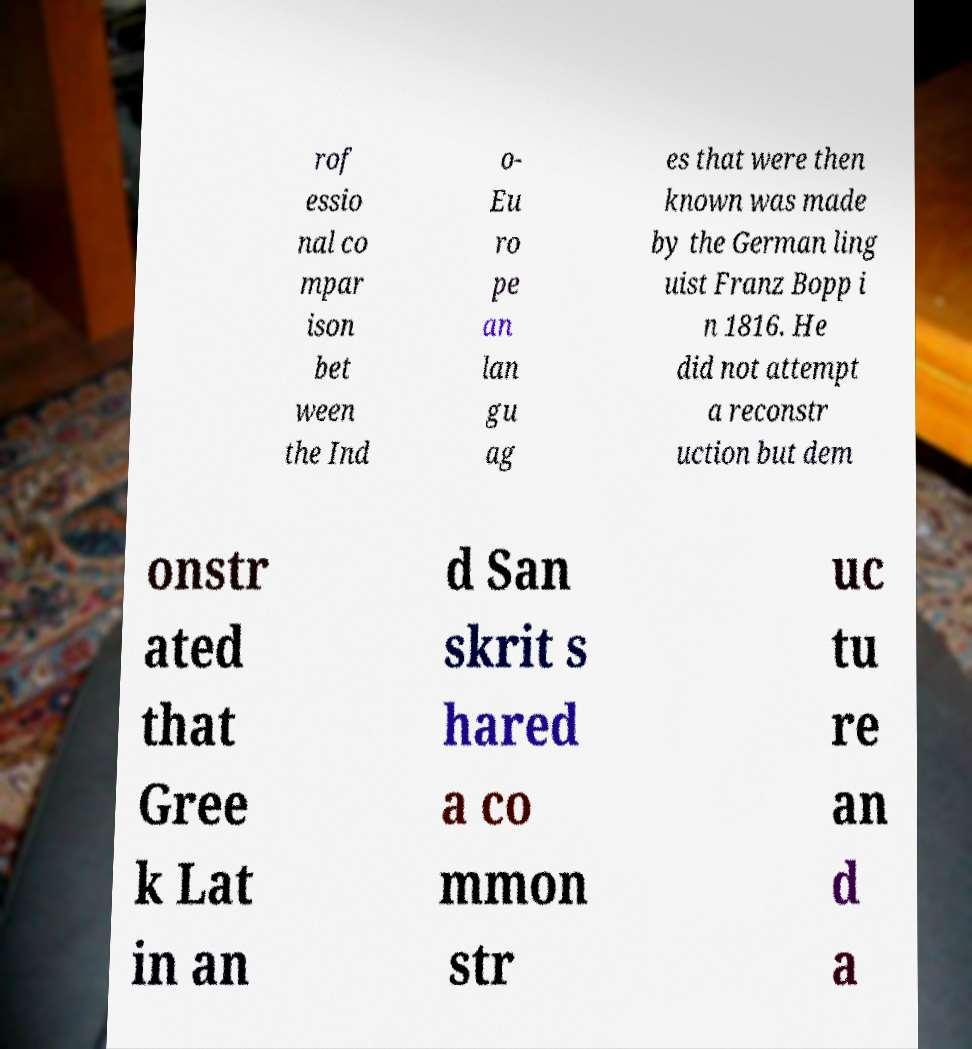Please read and relay the text visible in this image. What does it say? rof essio nal co mpar ison bet ween the Ind o- Eu ro pe an lan gu ag es that were then known was made by the German ling uist Franz Bopp i n 1816. He did not attempt a reconstr uction but dem onstr ated that Gree k Lat in an d San skrit s hared a co mmon str uc tu re an d a 